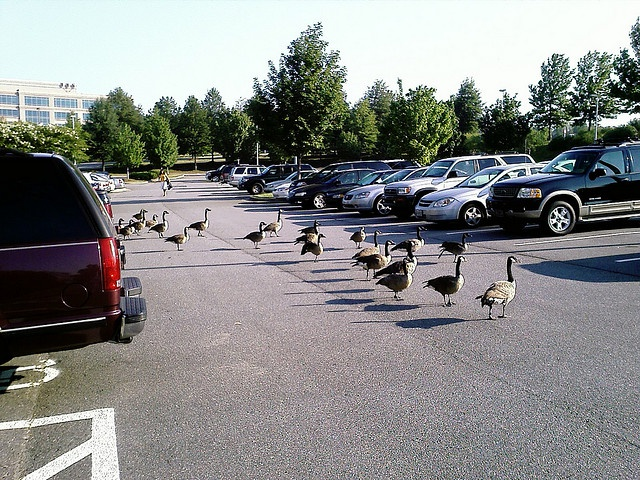Describe the objects in this image and their specific colors. I can see truck in lightblue, black, gray, darkgray, and maroon tones, truck in lightblue, black, gray, blue, and navy tones, car in lightblue, black, white, gray, and darkgray tones, car in lightblue, black, white, gray, and darkgray tones, and bird in lightblue, black, lightgray, darkgray, and gray tones in this image. 